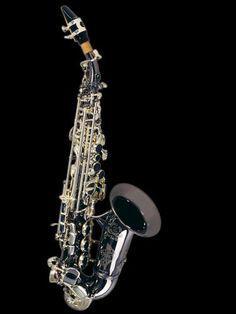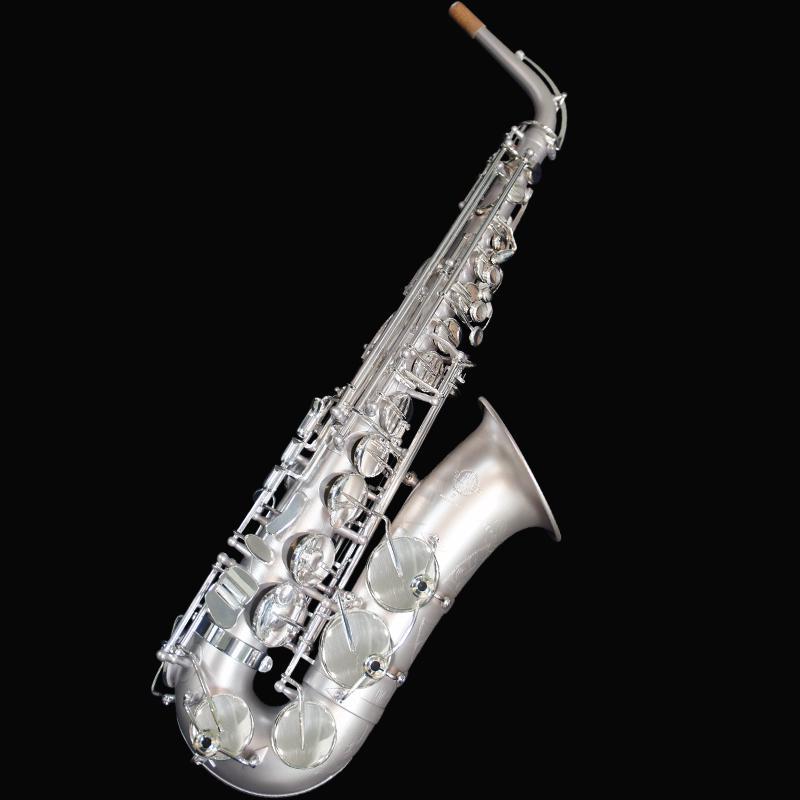The first image is the image on the left, the second image is the image on the right. Given the left and right images, does the statement "Each image contains one saxophone displayed at some angle, with its bell facing rightward, and one image features a silver saxophone with a brown tip at one end." hold true? Answer yes or no. Yes. 